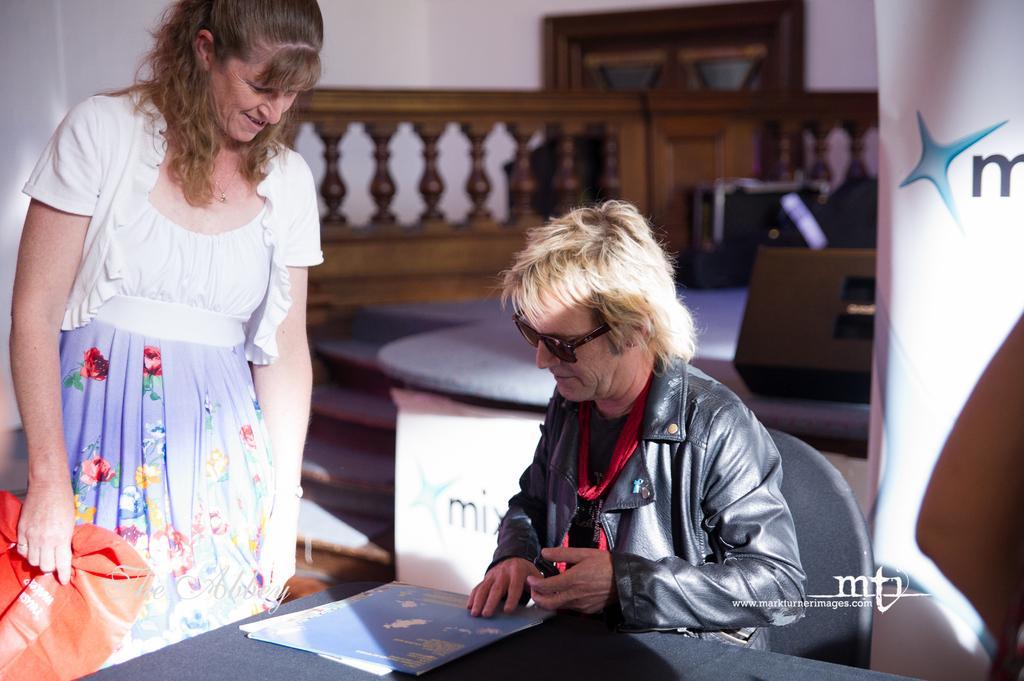How would you summarize this image in a sentence or two? This image is taken indoors. At the bottom of the image there is a table with a few papers on it. On the right side of the image there is a banner with a text on it. On the left side of the image a woman is standing on the floor and she is holding a cover in her hand. In the middle of the image a man is sitting on the chair. In the background there is a wall with a door. There is a railing and there is a table with a few things on it. 